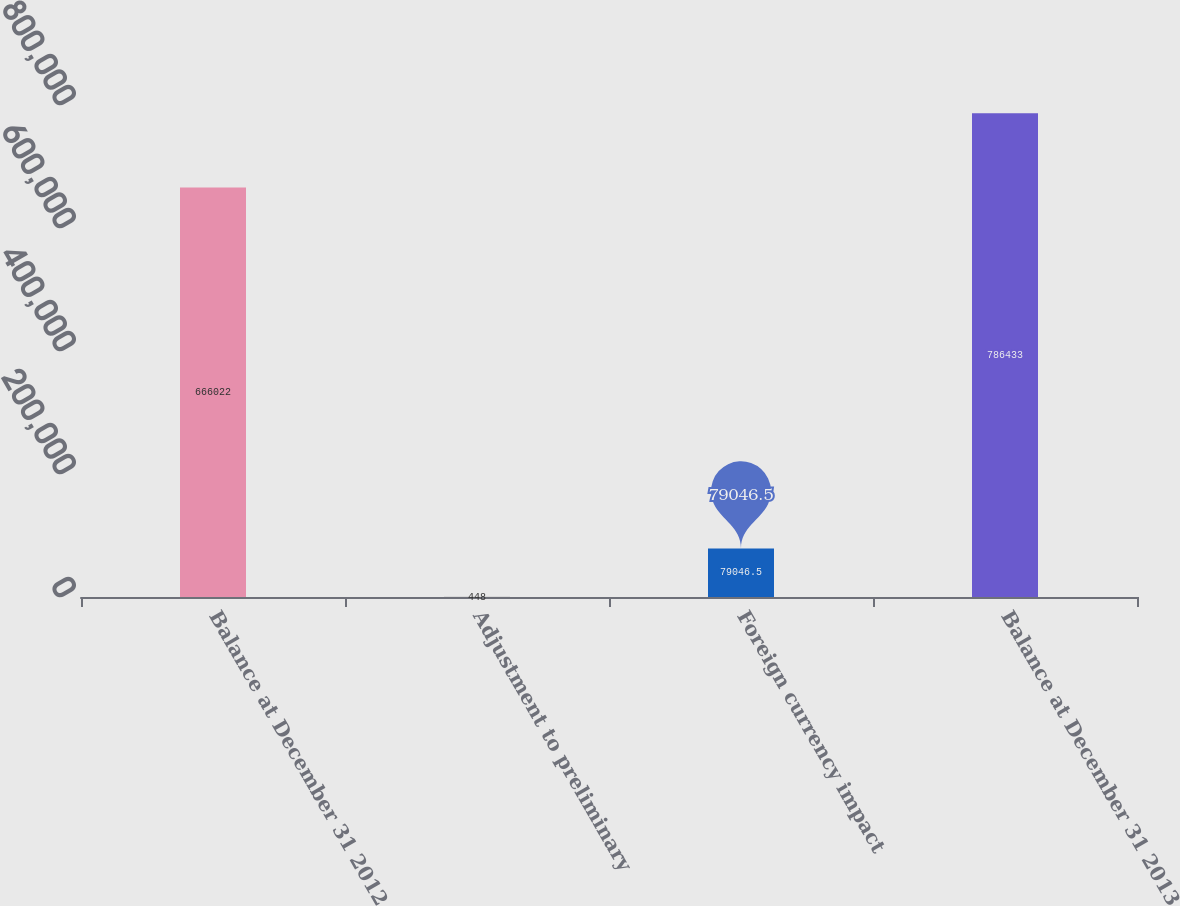Convert chart. <chart><loc_0><loc_0><loc_500><loc_500><bar_chart><fcel>Balance at December 31 2012<fcel>Adjustment to preliminary<fcel>Foreign currency impact<fcel>Balance at December 31 2013<nl><fcel>666022<fcel>448<fcel>79046.5<fcel>786433<nl></chart> 